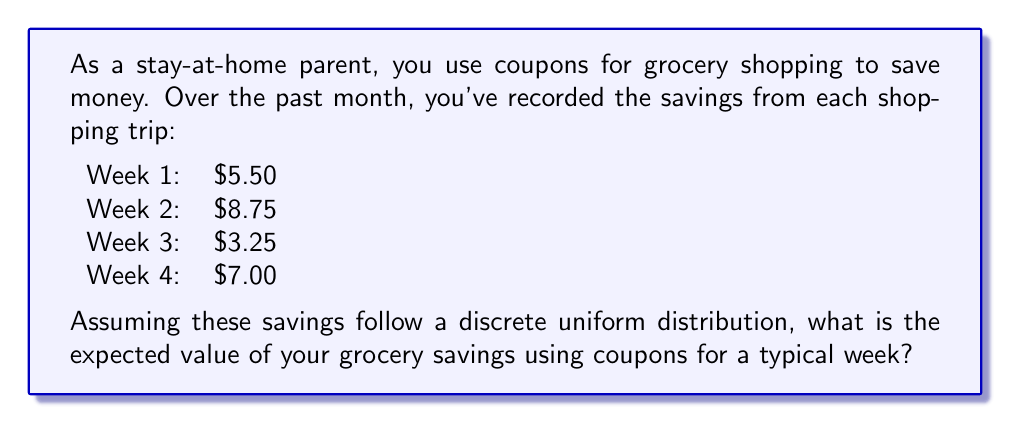What is the answer to this math problem? To solve this problem, we'll follow these steps:

1. Identify the random variable:
   Let X be the savings from coupons in a week.

2. Determine the possible values of X:
   X can take on the values $5.50, $8.75, $3.25, and $7.00.

3. Calculate the probability of each value:
   Since we're assuming a discrete uniform distribution, each value has an equal probability of occurring. With 4 possible values, the probability of each is:
   
   $P(X = x) = \frac{1}{4} = 0.25$

4. Calculate the expected value:
   The expected value is given by the formula:
   
   $E(X) = \sum_{i=1}^{n} x_i \cdot P(X = x_i)$

   Where $x_i$ are the possible values of X, and $P(X = x_i)$ is the probability of each value.

5. Plug in the values:

   $E(X) = 5.50 \cdot 0.25 + 8.75 \cdot 0.25 + 3.25 \cdot 0.25 + 7.00 \cdot 0.25$

6. Simplify:

   $E(X) = 0.25(5.50 + 8.75 + 3.25 + 7.00)$
   $E(X) = 0.25(24.50)$
   $E(X) = 6.125$

Therefore, the expected value of grocery savings using coupons for a typical week is $6.125.
Answer: $6.125 